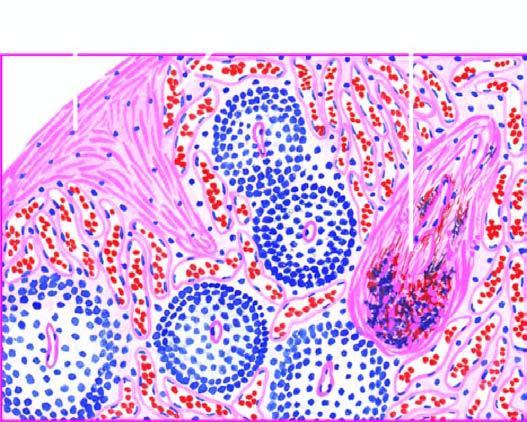re the alveolar spaces as well as interstitium dilated and congested?
Answer the question using a single word or phrase. No 